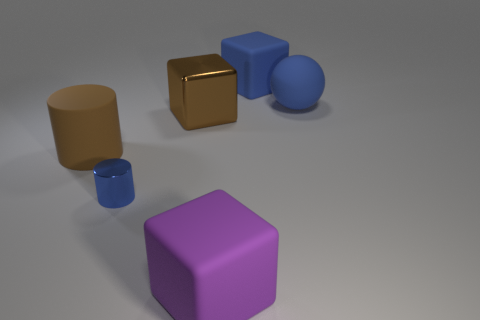Subtract all large matte blocks. How many blocks are left? 1 Add 2 balls. How many objects exist? 8 Subtract all blue cubes. How many cubes are left? 2 Subtract all cylinders. How many objects are left? 4 Subtract 1 balls. How many balls are left? 0 Subtract all red balls. How many blue blocks are left? 1 Add 6 purple things. How many purple things are left? 7 Add 2 tiny metallic things. How many tiny metallic things exist? 3 Subtract 0 cyan spheres. How many objects are left? 6 Subtract all green spheres. Subtract all gray cylinders. How many spheres are left? 1 